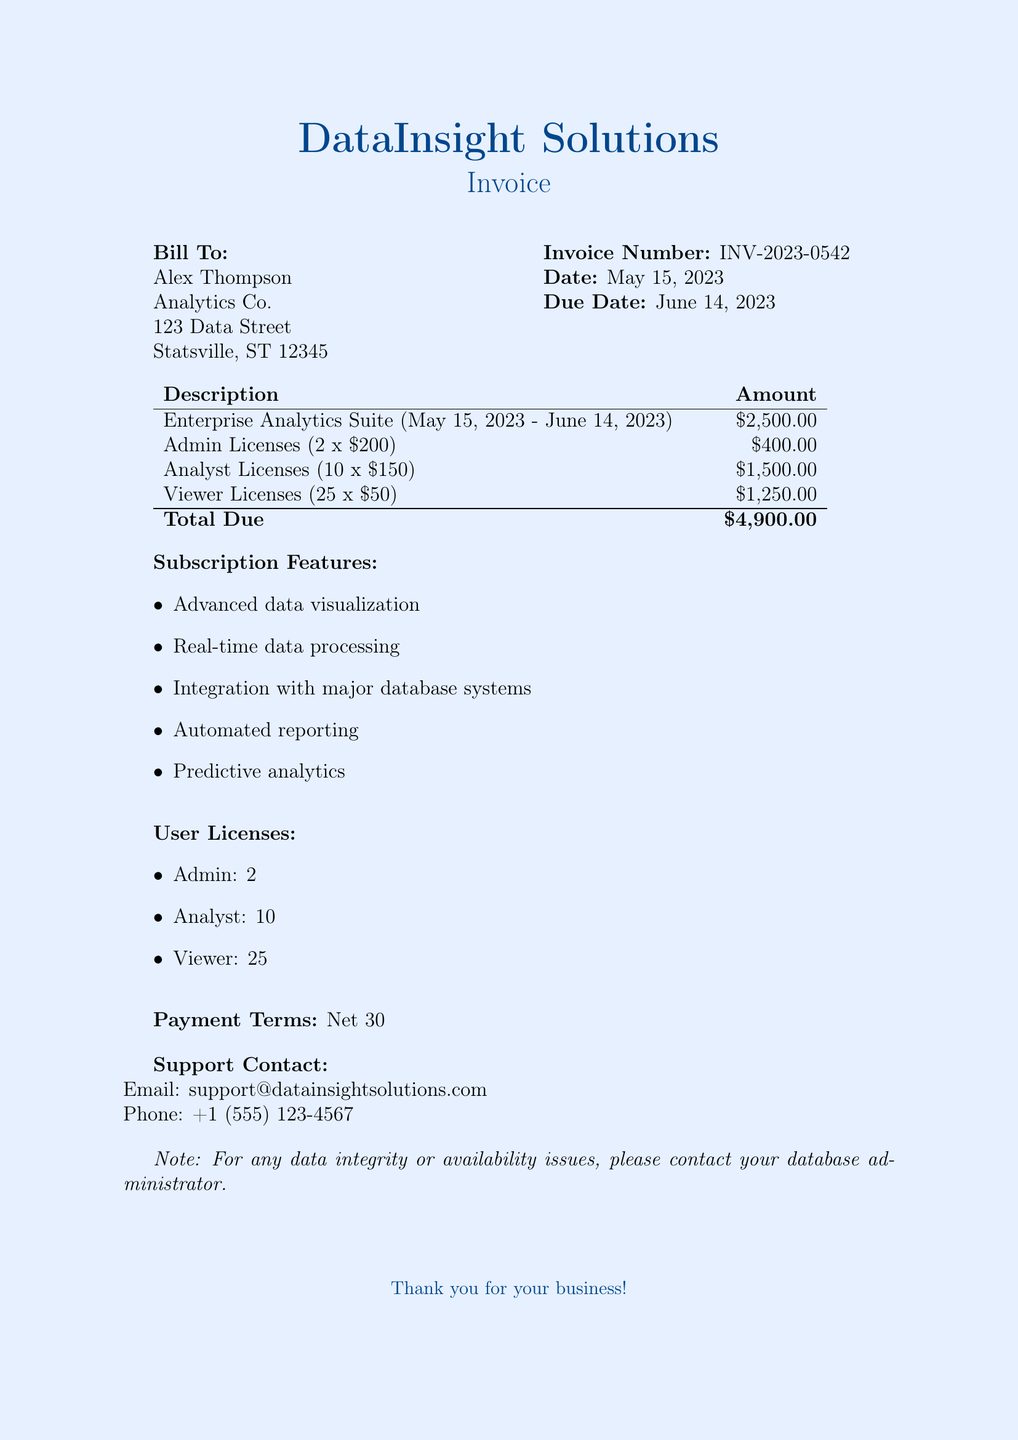What is the invoice number? The invoice number is a unique identifier for the billing document, specified in the document as INV-2023-0542.
Answer: INV-2023-0542 What is the total amount due? The total amount due is stated at the bottom of the amount table, which sums all individual charges.
Answer: $4,900.00 What is the subscription start date? The subscription start date is mentioned in the description of the Enterprise Analytics Suite service period as May 15, 2023.
Answer: May 15, 2023 How many analyst licenses are included? The document lists the number of analyst licenses in the user licenses section, which states there are 10.
Answer: 10 What are the payment terms? The payment terms are specified in the document to be Net 30, indicating the payment is due within 30 days.
Answer: Net 30 What is one feature included in the subscription? The features of the subscription are listed, and any single feature is an acceptable answer, such as "Advanced data visualization."
Answer: Advanced data visualization When is the due date for the invoice? The due date is provided in the invoice details sections, listed as June 14, 2023.
Answer: June 14, 2023 How many viewer licenses are included? The document details the user licenses, mentioning that there are 25 viewer licenses included in the subscription.
Answer: 25 Who is the support contact email? The support contact email is specified in the document, making it easy to reach out for assistance, stated as support@datainsightsolutions.com.
Answer: support@datainsightsolutions.com 